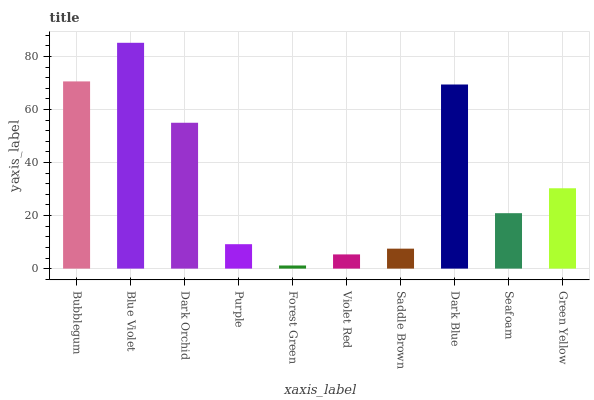Is Forest Green the minimum?
Answer yes or no. Yes. Is Blue Violet the maximum?
Answer yes or no. Yes. Is Dark Orchid the minimum?
Answer yes or no. No. Is Dark Orchid the maximum?
Answer yes or no. No. Is Blue Violet greater than Dark Orchid?
Answer yes or no. Yes. Is Dark Orchid less than Blue Violet?
Answer yes or no. Yes. Is Dark Orchid greater than Blue Violet?
Answer yes or no. No. Is Blue Violet less than Dark Orchid?
Answer yes or no. No. Is Green Yellow the high median?
Answer yes or no. Yes. Is Seafoam the low median?
Answer yes or no. Yes. Is Dark Orchid the high median?
Answer yes or no. No. Is Blue Violet the low median?
Answer yes or no. No. 